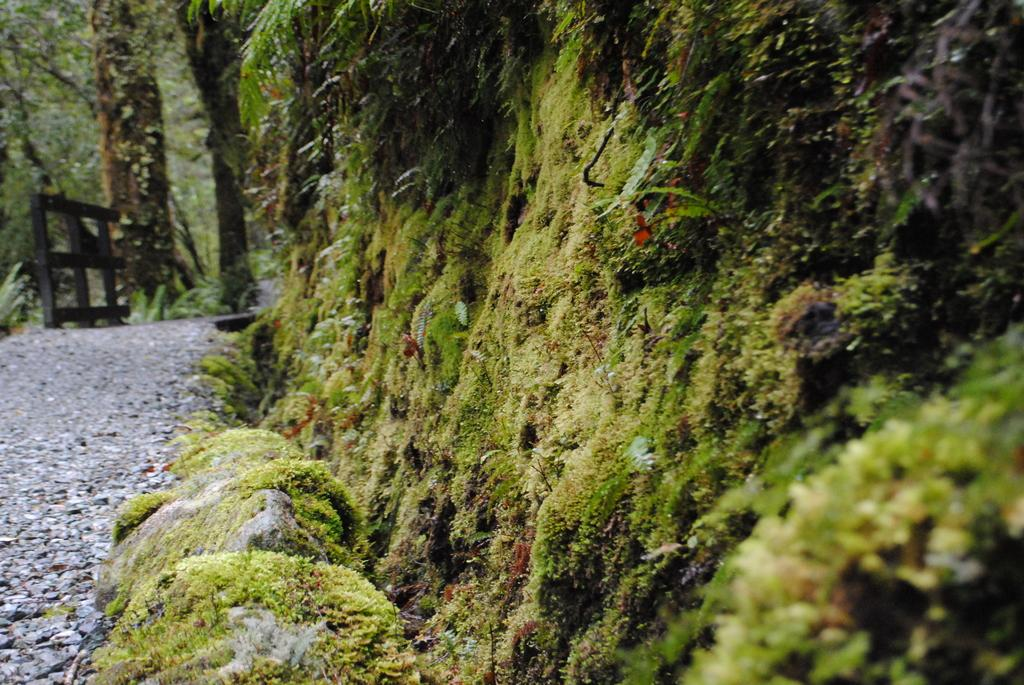What type of vegetation can be seen in the image? There is moss in the image. What other natural elements are present in the image? There are rocks in the image. Where is the path located in relation to the rocks? The path is on the left side of the rocks. What is located on the left side of the rocks? There is an object on the left side of the rocks. What can be seen behind the object? There are trees behind the object. What type of leaf can be seen on the quartz in the image? There is no leaf or quartz present in the image. How does the ray of sunlight affect the moss in the image? There is no mention of sunlight in the image, so it cannot be determined how it affects the moss. 